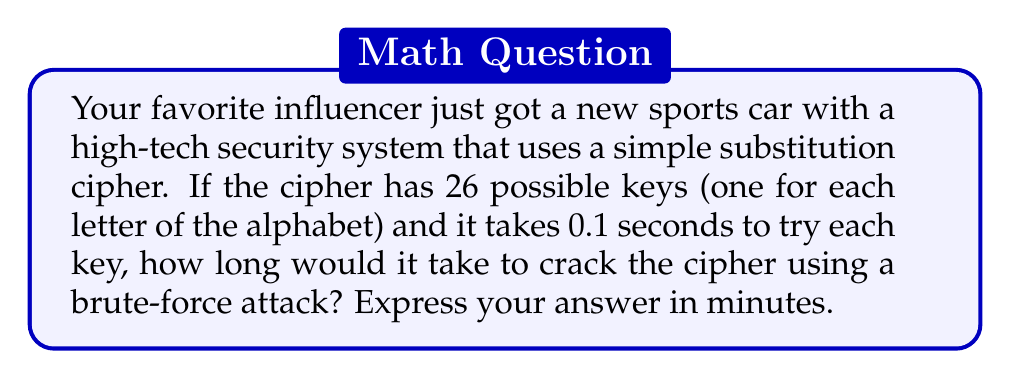Provide a solution to this math problem. Let's approach this step-by-step:

1. Understand the given information:
   - The cipher has 26 possible keys
   - It takes 0.1 seconds to try each key

2. Calculate the total time in seconds:
   $$\text{Total time (seconds)} = \text{Number of keys} \times \text{Time per key}$$
   $$\text{Total time (seconds)} = 26 \times 0.1 = 2.6 \text{ seconds}$$

3. Convert seconds to minutes:
   $$\text{Time (minutes)} = \frac{\text{Time (seconds)}}{60}$$
   $$\text{Time (minutes)} = \frac{2.6}{60} \approx 0.0433 \text{ minutes}$$

4. Round to the nearest hundredth:
   $$0.0433 \text{ minutes} \approx 0.04 \text{ minutes}$$

Therefore, it would take approximately 0.04 minutes to crack the cipher using a brute-force attack.
Answer: 0.04 minutes 